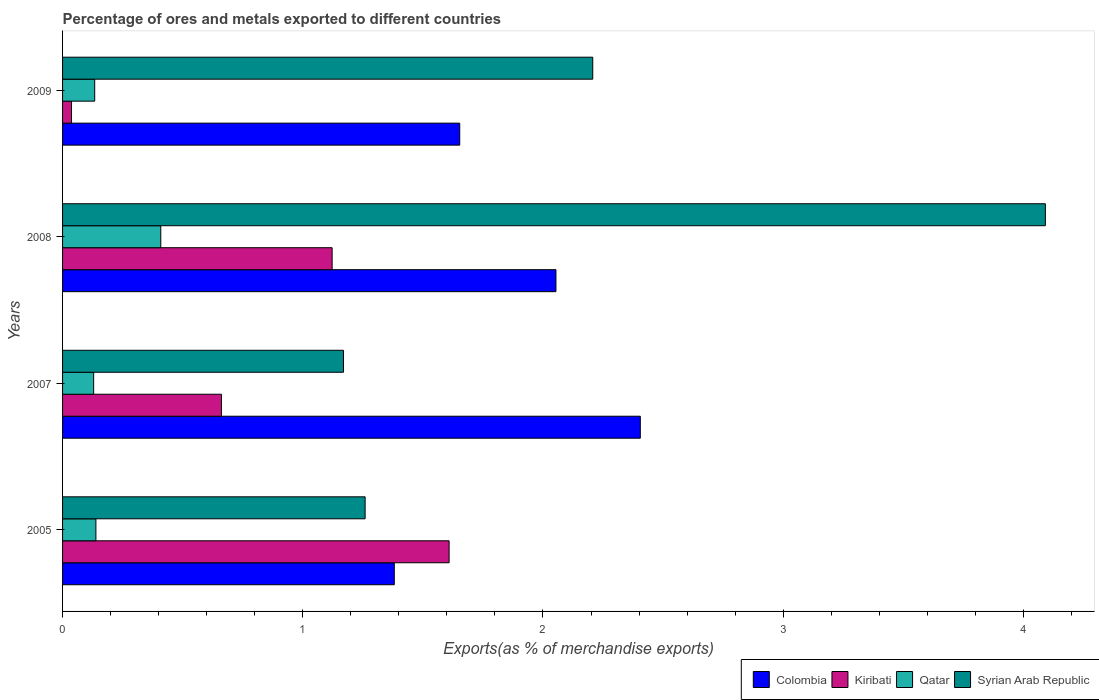How many different coloured bars are there?
Your answer should be very brief. 4. How many groups of bars are there?
Ensure brevity in your answer.  4. Are the number of bars per tick equal to the number of legend labels?
Keep it short and to the point. Yes. Are the number of bars on each tick of the Y-axis equal?
Ensure brevity in your answer.  Yes. In how many cases, is the number of bars for a given year not equal to the number of legend labels?
Your answer should be compact. 0. What is the percentage of exports to different countries in Colombia in 2008?
Provide a short and direct response. 2.05. Across all years, what is the maximum percentage of exports to different countries in Qatar?
Ensure brevity in your answer.  0.41. Across all years, what is the minimum percentage of exports to different countries in Colombia?
Ensure brevity in your answer.  1.38. In which year was the percentage of exports to different countries in Kiribati maximum?
Your response must be concise. 2005. In which year was the percentage of exports to different countries in Kiribati minimum?
Ensure brevity in your answer.  2009. What is the total percentage of exports to different countries in Kiribati in the graph?
Give a very brief answer. 3.43. What is the difference between the percentage of exports to different countries in Qatar in 2007 and that in 2009?
Ensure brevity in your answer.  -0. What is the difference between the percentage of exports to different countries in Colombia in 2005 and the percentage of exports to different countries in Qatar in 2007?
Your answer should be very brief. 1.25. What is the average percentage of exports to different countries in Kiribati per year?
Ensure brevity in your answer.  0.86. In the year 2005, what is the difference between the percentage of exports to different countries in Colombia and percentage of exports to different countries in Syrian Arab Republic?
Make the answer very short. 0.12. In how many years, is the percentage of exports to different countries in Syrian Arab Republic greater than 2.4 %?
Offer a very short reply. 1. What is the ratio of the percentage of exports to different countries in Syrian Arab Republic in 2005 to that in 2008?
Your response must be concise. 0.31. Is the percentage of exports to different countries in Kiribati in 2005 less than that in 2007?
Give a very brief answer. No. What is the difference between the highest and the second highest percentage of exports to different countries in Colombia?
Make the answer very short. 0.35. What is the difference between the highest and the lowest percentage of exports to different countries in Qatar?
Offer a very short reply. 0.28. What does the 3rd bar from the top in 2008 represents?
Your response must be concise. Kiribati. What does the 2nd bar from the bottom in 2005 represents?
Offer a very short reply. Kiribati. How many bars are there?
Give a very brief answer. 16. Are all the bars in the graph horizontal?
Your answer should be compact. Yes. How many years are there in the graph?
Keep it short and to the point. 4. What is the difference between two consecutive major ticks on the X-axis?
Make the answer very short. 1. Are the values on the major ticks of X-axis written in scientific E-notation?
Your answer should be compact. No. Does the graph contain any zero values?
Your response must be concise. No. Does the graph contain grids?
Provide a short and direct response. No. How many legend labels are there?
Your answer should be compact. 4. What is the title of the graph?
Provide a short and direct response. Percentage of ores and metals exported to different countries. What is the label or title of the X-axis?
Your answer should be compact. Exports(as % of merchandise exports). What is the Exports(as % of merchandise exports) in Colombia in 2005?
Provide a succinct answer. 1.38. What is the Exports(as % of merchandise exports) of Kiribati in 2005?
Provide a succinct answer. 1.61. What is the Exports(as % of merchandise exports) in Qatar in 2005?
Ensure brevity in your answer.  0.14. What is the Exports(as % of merchandise exports) in Syrian Arab Republic in 2005?
Offer a very short reply. 1.26. What is the Exports(as % of merchandise exports) of Colombia in 2007?
Give a very brief answer. 2.41. What is the Exports(as % of merchandise exports) in Kiribati in 2007?
Ensure brevity in your answer.  0.66. What is the Exports(as % of merchandise exports) of Qatar in 2007?
Your response must be concise. 0.13. What is the Exports(as % of merchandise exports) of Syrian Arab Republic in 2007?
Offer a very short reply. 1.17. What is the Exports(as % of merchandise exports) in Colombia in 2008?
Make the answer very short. 2.05. What is the Exports(as % of merchandise exports) of Kiribati in 2008?
Your answer should be compact. 1.12. What is the Exports(as % of merchandise exports) in Qatar in 2008?
Provide a short and direct response. 0.41. What is the Exports(as % of merchandise exports) in Syrian Arab Republic in 2008?
Provide a short and direct response. 4.09. What is the Exports(as % of merchandise exports) of Colombia in 2009?
Ensure brevity in your answer.  1.65. What is the Exports(as % of merchandise exports) in Kiribati in 2009?
Your answer should be compact. 0.04. What is the Exports(as % of merchandise exports) of Qatar in 2009?
Make the answer very short. 0.13. What is the Exports(as % of merchandise exports) of Syrian Arab Republic in 2009?
Keep it short and to the point. 2.21. Across all years, what is the maximum Exports(as % of merchandise exports) of Colombia?
Ensure brevity in your answer.  2.41. Across all years, what is the maximum Exports(as % of merchandise exports) of Kiribati?
Keep it short and to the point. 1.61. Across all years, what is the maximum Exports(as % of merchandise exports) in Qatar?
Provide a short and direct response. 0.41. Across all years, what is the maximum Exports(as % of merchandise exports) of Syrian Arab Republic?
Offer a terse response. 4.09. Across all years, what is the minimum Exports(as % of merchandise exports) of Colombia?
Your answer should be very brief. 1.38. Across all years, what is the minimum Exports(as % of merchandise exports) in Kiribati?
Ensure brevity in your answer.  0.04. Across all years, what is the minimum Exports(as % of merchandise exports) in Qatar?
Make the answer very short. 0.13. Across all years, what is the minimum Exports(as % of merchandise exports) in Syrian Arab Republic?
Offer a terse response. 1.17. What is the total Exports(as % of merchandise exports) of Colombia in the graph?
Give a very brief answer. 7.49. What is the total Exports(as % of merchandise exports) of Kiribati in the graph?
Your response must be concise. 3.43. What is the total Exports(as % of merchandise exports) in Qatar in the graph?
Your answer should be compact. 0.81. What is the total Exports(as % of merchandise exports) in Syrian Arab Republic in the graph?
Make the answer very short. 8.73. What is the difference between the Exports(as % of merchandise exports) of Colombia in 2005 and that in 2007?
Offer a terse response. -1.02. What is the difference between the Exports(as % of merchandise exports) of Kiribati in 2005 and that in 2007?
Offer a terse response. 0.95. What is the difference between the Exports(as % of merchandise exports) in Qatar in 2005 and that in 2007?
Your answer should be compact. 0.01. What is the difference between the Exports(as % of merchandise exports) in Syrian Arab Republic in 2005 and that in 2007?
Your answer should be compact. 0.09. What is the difference between the Exports(as % of merchandise exports) in Colombia in 2005 and that in 2008?
Provide a short and direct response. -0.67. What is the difference between the Exports(as % of merchandise exports) of Kiribati in 2005 and that in 2008?
Ensure brevity in your answer.  0.49. What is the difference between the Exports(as % of merchandise exports) of Qatar in 2005 and that in 2008?
Offer a terse response. -0.27. What is the difference between the Exports(as % of merchandise exports) in Syrian Arab Republic in 2005 and that in 2008?
Offer a terse response. -2.83. What is the difference between the Exports(as % of merchandise exports) of Colombia in 2005 and that in 2009?
Your answer should be very brief. -0.27. What is the difference between the Exports(as % of merchandise exports) in Kiribati in 2005 and that in 2009?
Give a very brief answer. 1.57. What is the difference between the Exports(as % of merchandise exports) of Qatar in 2005 and that in 2009?
Your response must be concise. 0.01. What is the difference between the Exports(as % of merchandise exports) of Syrian Arab Republic in 2005 and that in 2009?
Make the answer very short. -0.95. What is the difference between the Exports(as % of merchandise exports) in Colombia in 2007 and that in 2008?
Provide a short and direct response. 0.35. What is the difference between the Exports(as % of merchandise exports) in Kiribati in 2007 and that in 2008?
Give a very brief answer. -0.46. What is the difference between the Exports(as % of merchandise exports) of Qatar in 2007 and that in 2008?
Provide a short and direct response. -0.28. What is the difference between the Exports(as % of merchandise exports) in Syrian Arab Republic in 2007 and that in 2008?
Make the answer very short. -2.92. What is the difference between the Exports(as % of merchandise exports) in Colombia in 2007 and that in 2009?
Provide a short and direct response. 0.75. What is the difference between the Exports(as % of merchandise exports) of Kiribati in 2007 and that in 2009?
Provide a succinct answer. 0.62. What is the difference between the Exports(as % of merchandise exports) of Qatar in 2007 and that in 2009?
Provide a succinct answer. -0. What is the difference between the Exports(as % of merchandise exports) of Syrian Arab Republic in 2007 and that in 2009?
Give a very brief answer. -1.04. What is the difference between the Exports(as % of merchandise exports) in Colombia in 2008 and that in 2009?
Ensure brevity in your answer.  0.4. What is the difference between the Exports(as % of merchandise exports) of Kiribati in 2008 and that in 2009?
Your answer should be compact. 1.08. What is the difference between the Exports(as % of merchandise exports) of Qatar in 2008 and that in 2009?
Your answer should be very brief. 0.28. What is the difference between the Exports(as % of merchandise exports) of Syrian Arab Republic in 2008 and that in 2009?
Your answer should be compact. 1.88. What is the difference between the Exports(as % of merchandise exports) of Colombia in 2005 and the Exports(as % of merchandise exports) of Kiribati in 2007?
Your answer should be compact. 0.72. What is the difference between the Exports(as % of merchandise exports) in Colombia in 2005 and the Exports(as % of merchandise exports) in Qatar in 2007?
Your answer should be very brief. 1.25. What is the difference between the Exports(as % of merchandise exports) of Colombia in 2005 and the Exports(as % of merchandise exports) of Syrian Arab Republic in 2007?
Offer a very short reply. 0.21. What is the difference between the Exports(as % of merchandise exports) in Kiribati in 2005 and the Exports(as % of merchandise exports) in Qatar in 2007?
Provide a succinct answer. 1.48. What is the difference between the Exports(as % of merchandise exports) of Kiribati in 2005 and the Exports(as % of merchandise exports) of Syrian Arab Republic in 2007?
Provide a succinct answer. 0.44. What is the difference between the Exports(as % of merchandise exports) in Qatar in 2005 and the Exports(as % of merchandise exports) in Syrian Arab Republic in 2007?
Ensure brevity in your answer.  -1.03. What is the difference between the Exports(as % of merchandise exports) in Colombia in 2005 and the Exports(as % of merchandise exports) in Kiribati in 2008?
Your answer should be compact. 0.26. What is the difference between the Exports(as % of merchandise exports) in Colombia in 2005 and the Exports(as % of merchandise exports) in Qatar in 2008?
Offer a very short reply. 0.97. What is the difference between the Exports(as % of merchandise exports) of Colombia in 2005 and the Exports(as % of merchandise exports) of Syrian Arab Republic in 2008?
Your response must be concise. -2.71. What is the difference between the Exports(as % of merchandise exports) in Kiribati in 2005 and the Exports(as % of merchandise exports) in Qatar in 2008?
Ensure brevity in your answer.  1.2. What is the difference between the Exports(as % of merchandise exports) in Kiribati in 2005 and the Exports(as % of merchandise exports) in Syrian Arab Republic in 2008?
Give a very brief answer. -2.48. What is the difference between the Exports(as % of merchandise exports) of Qatar in 2005 and the Exports(as % of merchandise exports) of Syrian Arab Republic in 2008?
Your answer should be compact. -3.95. What is the difference between the Exports(as % of merchandise exports) in Colombia in 2005 and the Exports(as % of merchandise exports) in Kiribati in 2009?
Give a very brief answer. 1.34. What is the difference between the Exports(as % of merchandise exports) in Colombia in 2005 and the Exports(as % of merchandise exports) in Qatar in 2009?
Your answer should be compact. 1.25. What is the difference between the Exports(as % of merchandise exports) of Colombia in 2005 and the Exports(as % of merchandise exports) of Syrian Arab Republic in 2009?
Keep it short and to the point. -0.83. What is the difference between the Exports(as % of merchandise exports) of Kiribati in 2005 and the Exports(as % of merchandise exports) of Qatar in 2009?
Make the answer very short. 1.48. What is the difference between the Exports(as % of merchandise exports) of Kiribati in 2005 and the Exports(as % of merchandise exports) of Syrian Arab Republic in 2009?
Provide a short and direct response. -0.6. What is the difference between the Exports(as % of merchandise exports) of Qatar in 2005 and the Exports(as % of merchandise exports) of Syrian Arab Republic in 2009?
Provide a succinct answer. -2.07. What is the difference between the Exports(as % of merchandise exports) in Colombia in 2007 and the Exports(as % of merchandise exports) in Kiribati in 2008?
Your answer should be compact. 1.28. What is the difference between the Exports(as % of merchandise exports) of Colombia in 2007 and the Exports(as % of merchandise exports) of Qatar in 2008?
Offer a terse response. 2. What is the difference between the Exports(as % of merchandise exports) of Colombia in 2007 and the Exports(as % of merchandise exports) of Syrian Arab Republic in 2008?
Offer a terse response. -1.69. What is the difference between the Exports(as % of merchandise exports) in Kiribati in 2007 and the Exports(as % of merchandise exports) in Qatar in 2008?
Keep it short and to the point. 0.25. What is the difference between the Exports(as % of merchandise exports) in Kiribati in 2007 and the Exports(as % of merchandise exports) in Syrian Arab Republic in 2008?
Make the answer very short. -3.43. What is the difference between the Exports(as % of merchandise exports) in Qatar in 2007 and the Exports(as % of merchandise exports) in Syrian Arab Republic in 2008?
Keep it short and to the point. -3.96. What is the difference between the Exports(as % of merchandise exports) in Colombia in 2007 and the Exports(as % of merchandise exports) in Kiribati in 2009?
Keep it short and to the point. 2.37. What is the difference between the Exports(as % of merchandise exports) of Colombia in 2007 and the Exports(as % of merchandise exports) of Qatar in 2009?
Provide a succinct answer. 2.27. What is the difference between the Exports(as % of merchandise exports) of Colombia in 2007 and the Exports(as % of merchandise exports) of Syrian Arab Republic in 2009?
Ensure brevity in your answer.  0.2. What is the difference between the Exports(as % of merchandise exports) of Kiribati in 2007 and the Exports(as % of merchandise exports) of Qatar in 2009?
Provide a short and direct response. 0.53. What is the difference between the Exports(as % of merchandise exports) in Kiribati in 2007 and the Exports(as % of merchandise exports) in Syrian Arab Republic in 2009?
Give a very brief answer. -1.55. What is the difference between the Exports(as % of merchandise exports) of Qatar in 2007 and the Exports(as % of merchandise exports) of Syrian Arab Republic in 2009?
Offer a terse response. -2.08. What is the difference between the Exports(as % of merchandise exports) in Colombia in 2008 and the Exports(as % of merchandise exports) in Kiribati in 2009?
Keep it short and to the point. 2.02. What is the difference between the Exports(as % of merchandise exports) of Colombia in 2008 and the Exports(as % of merchandise exports) of Qatar in 2009?
Offer a very short reply. 1.92. What is the difference between the Exports(as % of merchandise exports) of Colombia in 2008 and the Exports(as % of merchandise exports) of Syrian Arab Republic in 2009?
Offer a very short reply. -0.15. What is the difference between the Exports(as % of merchandise exports) of Kiribati in 2008 and the Exports(as % of merchandise exports) of Qatar in 2009?
Ensure brevity in your answer.  0.99. What is the difference between the Exports(as % of merchandise exports) in Kiribati in 2008 and the Exports(as % of merchandise exports) in Syrian Arab Republic in 2009?
Offer a terse response. -1.08. What is the difference between the Exports(as % of merchandise exports) in Qatar in 2008 and the Exports(as % of merchandise exports) in Syrian Arab Republic in 2009?
Your answer should be compact. -1.8. What is the average Exports(as % of merchandise exports) of Colombia per year?
Your answer should be compact. 1.87. What is the average Exports(as % of merchandise exports) of Kiribati per year?
Your answer should be very brief. 0.86. What is the average Exports(as % of merchandise exports) of Qatar per year?
Provide a short and direct response. 0.2. What is the average Exports(as % of merchandise exports) of Syrian Arab Republic per year?
Offer a terse response. 2.18. In the year 2005, what is the difference between the Exports(as % of merchandise exports) in Colombia and Exports(as % of merchandise exports) in Kiribati?
Ensure brevity in your answer.  -0.23. In the year 2005, what is the difference between the Exports(as % of merchandise exports) in Colombia and Exports(as % of merchandise exports) in Qatar?
Give a very brief answer. 1.24. In the year 2005, what is the difference between the Exports(as % of merchandise exports) in Colombia and Exports(as % of merchandise exports) in Syrian Arab Republic?
Ensure brevity in your answer.  0.12. In the year 2005, what is the difference between the Exports(as % of merchandise exports) in Kiribati and Exports(as % of merchandise exports) in Qatar?
Your response must be concise. 1.47. In the year 2005, what is the difference between the Exports(as % of merchandise exports) of Kiribati and Exports(as % of merchandise exports) of Syrian Arab Republic?
Your answer should be very brief. 0.35. In the year 2005, what is the difference between the Exports(as % of merchandise exports) in Qatar and Exports(as % of merchandise exports) in Syrian Arab Republic?
Provide a short and direct response. -1.12. In the year 2007, what is the difference between the Exports(as % of merchandise exports) of Colombia and Exports(as % of merchandise exports) of Kiribati?
Provide a short and direct response. 1.74. In the year 2007, what is the difference between the Exports(as % of merchandise exports) in Colombia and Exports(as % of merchandise exports) in Qatar?
Ensure brevity in your answer.  2.28. In the year 2007, what is the difference between the Exports(as % of merchandise exports) in Colombia and Exports(as % of merchandise exports) in Syrian Arab Republic?
Your answer should be compact. 1.24. In the year 2007, what is the difference between the Exports(as % of merchandise exports) in Kiribati and Exports(as % of merchandise exports) in Qatar?
Provide a short and direct response. 0.53. In the year 2007, what is the difference between the Exports(as % of merchandise exports) in Kiribati and Exports(as % of merchandise exports) in Syrian Arab Republic?
Provide a short and direct response. -0.51. In the year 2007, what is the difference between the Exports(as % of merchandise exports) of Qatar and Exports(as % of merchandise exports) of Syrian Arab Republic?
Provide a succinct answer. -1.04. In the year 2008, what is the difference between the Exports(as % of merchandise exports) in Colombia and Exports(as % of merchandise exports) in Kiribati?
Make the answer very short. 0.93. In the year 2008, what is the difference between the Exports(as % of merchandise exports) in Colombia and Exports(as % of merchandise exports) in Qatar?
Your answer should be very brief. 1.65. In the year 2008, what is the difference between the Exports(as % of merchandise exports) of Colombia and Exports(as % of merchandise exports) of Syrian Arab Republic?
Ensure brevity in your answer.  -2.04. In the year 2008, what is the difference between the Exports(as % of merchandise exports) of Kiribati and Exports(as % of merchandise exports) of Qatar?
Keep it short and to the point. 0.71. In the year 2008, what is the difference between the Exports(as % of merchandise exports) in Kiribati and Exports(as % of merchandise exports) in Syrian Arab Republic?
Ensure brevity in your answer.  -2.97. In the year 2008, what is the difference between the Exports(as % of merchandise exports) of Qatar and Exports(as % of merchandise exports) of Syrian Arab Republic?
Offer a terse response. -3.68. In the year 2009, what is the difference between the Exports(as % of merchandise exports) of Colombia and Exports(as % of merchandise exports) of Kiribati?
Ensure brevity in your answer.  1.62. In the year 2009, what is the difference between the Exports(as % of merchandise exports) of Colombia and Exports(as % of merchandise exports) of Qatar?
Your response must be concise. 1.52. In the year 2009, what is the difference between the Exports(as % of merchandise exports) of Colombia and Exports(as % of merchandise exports) of Syrian Arab Republic?
Your answer should be very brief. -0.55. In the year 2009, what is the difference between the Exports(as % of merchandise exports) in Kiribati and Exports(as % of merchandise exports) in Qatar?
Your response must be concise. -0.1. In the year 2009, what is the difference between the Exports(as % of merchandise exports) in Kiribati and Exports(as % of merchandise exports) in Syrian Arab Republic?
Give a very brief answer. -2.17. In the year 2009, what is the difference between the Exports(as % of merchandise exports) of Qatar and Exports(as % of merchandise exports) of Syrian Arab Republic?
Ensure brevity in your answer.  -2.07. What is the ratio of the Exports(as % of merchandise exports) of Colombia in 2005 to that in 2007?
Offer a terse response. 0.57. What is the ratio of the Exports(as % of merchandise exports) in Kiribati in 2005 to that in 2007?
Your response must be concise. 2.43. What is the ratio of the Exports(as % of merchandise exports) in Qatar in 2005 to that in 2007?
Give a very brief answer. 1.07. What is the ratio of the Exports(as % of merchandise exports) in Syrian Arab Republic in 2005 to that in 2007?
Your answer should be very brief. 1.08. What is the ratio of the Exports(as % of merchandise exports) in Colombia in 2005 to that in 2008?
Give a very brief answer. 0.67. What is the ratio of the Exports(as % of merchandise exports) of Kiribati in 2005 to that in 2008?
Your response must be concise. 1.43. What is the ratio of the Exports(as % of merchandise exports) in Qatar in 2005 to that in 2008?
Provide a short and direct response. 0.34. What is the ratio of the Exports(as % of merchandise exports) in Syrian Arab Republic in 2005 to that in 2008?
Give a very brief answer. 0.31. What is the ratio of the Exports(as % of merchandise exports) in Colombia in 2005 to that in 2009?
Give a very brief answer. 0.84. What is the ratio of the Exports(as % of merchandise exports) of Kiribati in 2005 to that in 2009?
Your answer should be very brief. 43.16. What is the ratio of the Exports(as % of merchandise exports) of Qatar in 2005 to that in 2009?
Make the answer very short. 1.04. What is the ratio of the Exports(as % of merchandise exports) in Syrian Arab Republic in 2005 to that in 2009?
Give a very brief answer. 0.57. What is the ratio of the Exports(as % of merchandise exports) of Colombia in 2007 to that in 2008?
Your answer should be compact. 1.17. What is the ratio of the Exports(as % of merchandise exports) in Kiribati in 2007 to that in 2008?
Give a very brief answer. 0.59. What is the ratio of the Exports(as % of merchandise exports) in Qatar in 2007 to that in 2008?
Provide a succinct answer. 0.32. What is the ratio of the Exports(as % of merchandise exports) in Syrian Arab Republic in 2007 to that in 2008?
Give a very brief answer. 0.29. What is the ratio of the Exports(as % of merchandise exports) of Colombia in 2007 to that in 2009?
Offer a terse response. 1.45. What is the ratio of the Exports(as % of merchandise exports) in Kiribati in 2007 to that in 2009?
Your answer should be compact. 17.74. What is the ratio of the Exports(as % of merchandise exports) of Qatar in 2007 to that in 2009?
Keep it short and to the point. 0.97. What is the ratio of the Exports(as % of merchandise exports) of Syrian Arab Republic in 2007 to that in 2009?
Your answer should be compact. 0.53. What is the ratio of the Exports(as % of merchandise exports) in Colombia in 2008 to that in 2009?
Offer a terse response. 1.24. What is the ratio of the Exports(as % of merchandise exports) of Kiribati in 2008 to that in 2009?
Offer a terse response. 30.1. What is the ratio of the Exports(as % of merchandise exports) of Qatar in 2008 to that in 2009?
Provide a short and direct response. 3.06. What is the ratio of the Exports(as % of merchandise exports) of Syrian Arab Republic in 2008 to that in 2009?
Keep it short and to the point. 1.85. What is the difference between the highest and the second highest Exports(as % of merchandise exports) of Colombia?
Ensure brevity in your answer.  0.35. What is the difference between the highest and the second highest Exports(as % of merchandise exports) in Kiribati?
Your answer should be very brief. 0.49. What is the difference between the highest and the second highest Exports(as % of merchandise exports) in Qatar?
Give a very brief answer. 0.27. What is the difference between the highest and the second highest Exports(as % of merchandise exports) in Syrian Arab Republic?
Your answer should be very brief. 1.88. What is the difference between the highest and the lowest Exports(as % of merchandise exports) in Colombia?
Your response must be concise. 1.02. What is the difference between the highest and the lowest Exports(as % of merchandise exports) of Kiribati?
Your answer should be very brief. 1.57. What is the difference between the highest and the lowest Exports(as % of merchandise exports) of Qatar?
Provide a short and direct response. 0.28. What is the difference between the highest and the lowest Exports(as % of merchandise exports) in Syrian Arab Republic?
Give a very brief answer. 2.92. 